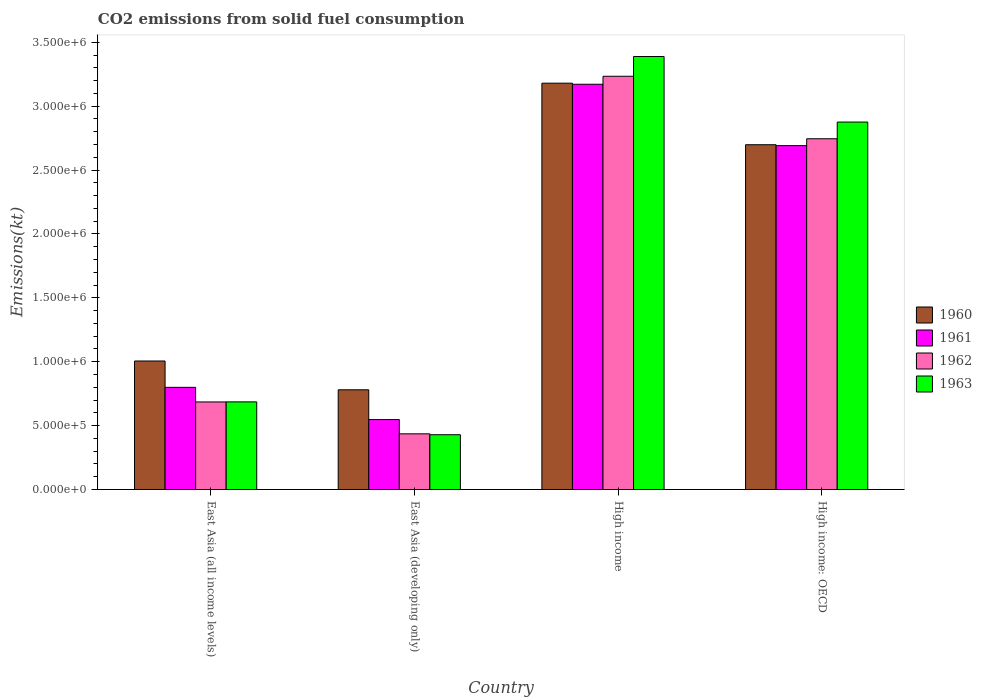How many different coloured bars are there?
Your answer should be compact. 4. Are the number of bars per tick equal to the number of legend labels?
Your answer should be very brief. Yes. How many bars are there on the 2nd tick from the left?
Your answer should be compact. 4. What is the label of the 1st group of bars from the left?
Your answer should be very brief. East Asia (all income levels). In how many cases, is the number of bars for a given country not equal to the number of legend labels?
Offer a terse response. 0. What is the amount of CO2 emitted in 1960 in East Asia (all income levels)?
Your answer should be compact. 1.01e+06. Across all countries, what is the maximum amount of CO2 emitted in 1962?
Offer a terse response. 3.23e+06. Across all countries, what is the minimum amount of CO2 emitted in 1963?
Offer a terse response. 4.29e+05. In which country was the amount of CO2 emitted in 1963 maximum?
Offer a terse response. High income. In which country was the amount of CO2 emitted in 1961 minimum?
Your answer should be compact. East Asia (developing only). What is the total amount of CO2 emitted in 1961 in the graph?
Your answer should be compact. 7.21e+06. What is the difference between the amount of CO2 emitted in 1961 in High income and that in High income: OECD?
Your answer should be compact. 4.80e+05. What is the difference between the amount of CO2 emitted in 1960 in East Asia (all income levels) and the amount of CO2 emitted in 1961 in High income: OECD?
Your response must be concise. -1.69e+06. What is the average amount of CO2 emitted in 1960 per country?
Provide a succinct answer. 1.92e+06. What is the difference between the amount of CO2 emitted of/in 1962 and amount of CO2 emitted of/in 1960 in East Asia (all income levels)?
Keep it short and to the point. -3.20e+05. What is the ratio of the amount of CO2 emitted in 1960 in East Asia (all income levels) to that in High income: OECD?
Keep it short and to the point. 0.37. Is the amount of CO2 emitted in 1960 in East Asia (all income levels) less than that in High income: OECD?
Your answer should be very brief. Yes. Is the difference between the amount of CO2 emitted in 1962 in East Asia (developing only) and High income greater than the difference between the amount of CO2 emitted in 1960 in East Asia (developing only) and High income?
Your answer should be compact. No. What is the difference between the highest and the second highest amount of CO2 emitted in 1961?
Your answer should be compact. 1.89e+06. What is the difference between the highest and the lowest amount of CO2 emitted in 1960?
Offer a terse response. 2.40e+06. In how many countries, is the amount of CO2 emitted in 1962 greater than the average amount of CO2 emitted in 1962 taken over all countries?
Make the answer very short. 2. Is the sum of the amount of CO2 emitted in 1961 in East Asia (all income levels) and High income greater than the maximum amount of CO2 emitted in 1960 across all countries?
Give a very brief answer. Yes. Is it the case that in every country, the sum of the amount of CO2 emitted in 1962 and amount of CO2 emitted in 1961 is greater than the sum of amount of CO2 emitted in 1963 and amount of CO2 emitted in 1960?
Offer a terse response. No. What does the 2nd bar from the right in East Asia (developing only) represents?
Offer a very short reply. 1962. Is it the case that in every country, the sum of the amount of CO2 emitted in 1962 and amount of CO2 emitted in 1961 is greater than the amount of CO2 emitted in 1963?
Keep it short and to the point. Yes. How many countries are there in the graph?
Your response must be concise. 4. Does the graph contain grids?
Make the answer very short. No. Where does the legend appear in the graph?
Your response must be concise. Center right. How many legend labels are there?
Provide a short and direct response. 4. How are the legend labels stacked?
Your answer should be compact. Vertical. What is the title of the graph?
Keep it short and to the point. CO2 emissions from solid fuel consumption. What is the label or title of the Y-axis?
Your answer should be very brief. Emissions(kt). What is the Emissions(kt) in 1960 in East Asia (all income levels)?
Make the answer very short. 1.01e+06. What is the Emissions(kt) in 1961 in East Asia (all income levels)?
Provide a succinct answer. 8.00e+05. What is the Emissions(kt) in 1962 in East Asia (all income levels)?
Keep it short and to the point. 6.85e+05. What is the Emissions(kt) of 1963 in East Asia (all income levels)?
Offer a terse response. 6.86e+05. What is the Emissions(kt) in 1960 in East Asia (developing only)?
Your answer should be compact. 7.80e+05. What is the Emissions(kt) of 1961 in East Asia (developing only)?
Make the answer very short. 5.48e+05. What is the Emissions(kt) of 1962 in East Asia (developing only)?
Ensure brevity in your answer.  4.36e+05. What is the Emissions(kt) of 1963 in East Asia (developing only)?
Your response must be concise. 4.29e+05. What is the Emissions(kt) in 1960 in High income?
Ensure brevity in your answer.  3.18e+06. What is the Emissions(kt) of 1961 in High income?
Keep it short and to the point. 3.17e+06. What is the Emissions(kt) of 1962 in High income?
Offer a very short reply. 3.23e+06. What is the Emissions(kt) in 1963 in High income?
Your answer should be very brief. 3.39e+06. What is the Emissions(kt) in 1960 in High income: OECD?
Your answer should be compact. 2.70e+06. What is the Emissions(kt) in 1961 in High income: OECD?
Provide a succinct answer. 2.69e+06. What is the Emissions(kt) of 1962 in High income: OECD?
Make the answer very short. 2.75e+06. What is the Emissions(kt) in 1963 in High income: OECD?
Ensure brevity in your answer.  2.88e+06. Across all countries, what is the maximum Emissions(kt) of 1960?
Ensure brevity in your answer.  3.18e+06. Across all countries, what is the maximum Emissions(kt) of 1961?
Your response must be concise. 3.17e+06. Across all countries, what is the maximum Emissions(kt) in 1962?
Make the answer very short. 3.23e+06. Across all countries, what is the maximum Emissions(kt) in 1963?
Your response must be concise. 3.39e+06. Across all countries, what is the minimum Emissions(kt) in 1960?
Your response must be concise. 7.80e+05. Across all countries, what is the minimum Emissions(kt) in 1961?
Make the answer very short. 5.48e+05. Across all countries, what is the minimum Emissions(kt) in 1962?
Offer a terse response. 4.36e+05. Across all countries, what is the minimum Emissions(kt) in 1963?
Your response must be concise. 4.29e+05. What is the total Emissions(kt) of 1960 in the graph?
Ensure brevity in your answer.  7.66e+06. What is the total Emissions(kt) of 1961 in the graph?
Offer a terse response. 7.21e+06. What is the total Emissions(kt) of 1962 in the graph?
Your response must be concise. 7.10e+06. What is the total Emissions(kt) of 1963 in the graph?
Offer a very short reply. 7.38e+06. What is the difference between the Emissions(kt) in 1960 in East Asia (all income levels) and that in East Asia (developing only)?
Make the answer very short. 2.25e+05. What is the difference between the Emissions(kt) of 1961 in East Asia (all income levels) and that in East Asia (developing only)?
Provide a short and direct response. 2.52e+05. What is the difference between the Emissions(kt) in 1962 in East Asia (all income levels) and that in East Asia (developing only)?
Offer a terse response. 2.50e+05. What is the difference between the Emissions(kt) of 1963 in East Asia (all income levels) and that in East Asia (developing only)?
Your answer should be very brief. 2.57e+05. What is the difference between the Emissions(kt) in 1960 in East Asia (all income levels) and that in High income?
Your response must be concise. -2.17e+06. What is the difference between the Emissions(kt) of 1961 in East Asia (all income levels) and that in High income?
Your answer should be compact. -2.37e+06. What is the difference between the Emissions(kt) of 1962 in East Asia (all income levels) and that in High income?
Offer a very short reply. -2.55e+06. What is the difference between the Emissions(kt) of 1963 in East Asia (all income levels) and that in High income?
Provide a succinct answer. -2.70e+06. What is the difference between the Emissions(kt) in 1960 in East Asia (all income levels) and that in High income: OECD?
Offer a terse response. -1.69e+06. What is the difference between the Emissions(kt) of 1961 in East Asia (all income levels) and that in High income: OECD?
Give a very brief answer. -1.89e+06. What is the difference between the Emissions(kt) of 1962 in East Asia (all income levels) and that in High income: OECD?
Offer a terse response. -2.06e+06. What is the difference between the Emissions(kt) of 1963 in East Asia (all income levels) and that in High income: OECD?
Make the answer very short. -2.19e+06. What is the difference between the Emissions(kt) in 1960 in East Asia (developing only) and that in High income?
Your answer should be compact. -2.40e+06. What is the difference between the Emissions(kt) of 1961 in East Asia (developing only) and that in High income?
Keep it short and to the point. -2.62e+06. What is the difference between the Emissions(kt) of 1962 in East Asia (developing only) and that in High income?
Offer a terse response. -2.80e+06. What is the difference between the Emissions(kt) of 1963 in East Asia (developing only) and that in High income?
Give a very brief answer. -2.96e+06. What is the difference between the Emissions(kt) in 1960 in East Asia (developing only) and that in High income: OECD?
Make the answer very short. -1.92e+06. What is the difference between the Emissions(kt) of 1961 in East Asia (developing only) and that in High income: OECD?
Provide a succinct answer. -2.14e+06. What is the difference between the Emissions(kt) of 1962 in East Asia (developing only) and that in High income: OECD?
Make the answer very short. -2.31e+06. What is the difference between the Emissions(kt) of 1963 in East Asia (developing only) and that in High income: OECD?
Keep it short and to the point. -2.45e+06. What is the difference between the Emissions(kt) of 1960 in High income and that in High income: OECD?
Your response must be concise. 4.82e+05. What is the difference between the Emissions(kt) in 1961 in High income and that in High income: OECD?
Your answer should be compact. 4.80e+05. What is the difference between the Emissions(kt) of 1962 in High income and that in High income: OECD?
Provide a short and direct response. 4.89e+05. What is the difference between the Emissions(kt) of 1963 in High income and that in High income: OECD?
Offer a terse response. 5.13e+05. What is the difference between the Emissions(kt) of 1960 in East Asia (all income levels) and the Emissions(kt) of 1961 in East Asia (developing only)?
Make the answer very short. 4.58e+05. What is the difference between the Emissions(kt) in 1960 in East Asia (all income levels) and the Emissions(kt) in 1962 in East Asia (developing only)?
Offer a terse response. 5.70e+05. What is the difference between the Emissions(kt) of 1960 in East Asia (all income levels) and the Emissions(kt) of 1963 in East Asia (developing only)?
Give a very brief answer. 5.77e+05. What is the difference between the Emissions(kt) of 1961 in East Asia (all income levels) and the Emissions(kt) of 1962 in East Asia (developing only)?
Your answer should be very brief. 3.64e+05. What is the difference between the Emissions(kt) in 1961 in East Asia (all income levels) and the Emissions(kt) in 1963 in East Asia (developing only)?
Ensure brevity in your answer.  3.71e+05. What is the difference between the Emissions(kt) of 1962 in East Asia (all income levels) and the Emissions(kt) of 1963 in East Asia (developing only)?
Offer a very short reply. 2.57e+05. What is the difference between the Emissions(kt) in 1960 in East Asia (all income levels) and the Emissions(kt) in 1961 in High income?
Provide a short and direct response. -2.17e+06. What is the difference between the Emissions(kt) in 1960 in East Asia (all income levels) and the Emissions(kt) in 1962 in High income?
Give a very brief answer. -2.23e+06. What is the difference between the Emissions(kt) of 1960 in East Asia (all income levels) and the Emissions(kt) of 1963 in High income?
Make the answer very short. -2.38e+06. What is the difference between the Emissions(kt) in 1961 in East Asia (all income levels) and the Emissions(kt) in 1962 in High income?
Ensure brevity in your answer.  -2.43e+06. What is the difference between the Emissions(kt) of 1961 in East Asia (all income levels) and the Emissions(kt) of 1963 in High income?
Provide a succinct answer. -2.59e+06. What is the difference between the Emissions(kt) of 1962 in East Asia (all income levels) and the Emissions(kt) of 1963 in High income?
Keep it short and to the point. -2.70e+06. What is the difference between the Emissions(kt) in 1960 in East Asia (all income levels) and the Emissions(kt) in 1961 in High income: OECD?
Offer a very short reply. -1.69e+06. What is the difference between the Emissions(kt) of 1960 in East Asia (all income levels) and the Emissions(kt) of 1962 in High income: OECD?
Make the answer very short. -1.74e+06. What is the difference between the Emissions(kt) in 1960 in East Asia (all income levels) and the Emissions(kt) in 1963 in High income: OECD?
Provide a short and direct response. -1.87e+06. What is the difference between the Emissions(kt) of 1961 in East Asia (all income levels) and the Emissions(kt) of 1962 in High income: OECD?
Provide a short and direct response. -1.95e+06. What is the difference between the Emissions(kt) of 1961 in East Asia (all income levels) and the Emissions(kt) of 1963 in High income: OECD?
Ensure brevity in your answer.  -2.08e+06. What is the difference between the Emissions(kt) of 1962 in East Asia (all income levels) and the Emissions(kt) of 1963 in High income: OECD?
Provide a short and direct response. -2.19e+06. What is the difference between the Emissions(kt) in 1960 in East Asia (developing only) and the Emissions(kt) in 1961 in High income?
Your answer should be compact. -2.39e+06. What is the difference between the Emissions(kt) of 1960 in East Asia (developing only) and the Emissions(kt) of 1962 in High income?
Offer a very short reply. -2.45e+06. What is the difference between the Emissions(kt) of 1960 in East Asia (developing only) and the Emissions(kt) of 1963 in High income?
Offer a very short reply. -2.61e+06. What is the difference between the Emissions(kt) in 1961 in East Asia (developing only) and the Emissions(kt) in 1962 in High income?
Your answer should be compact. -2.69e+06. What is the difference between the Emissions(kt) in 1961 in East Asia (developing only) and the Emissions(kt) in 1963 in High income?
Your answer should be compact. -2.84e+06. What is the difference between the Emissions(kt) in 1962 in East Asia (developing only) and the Emissions(kt) in 1963 in High income?
Ensure brevity in your answer.  -2.95e+06. What is the difference between the Emissions(kt) in 1960 in East Asia (developing only) and the Emissions(kt) in 1961 in High income: OECD?
Offer a terse response. -1.91e+06. What is the difference between the Emissions(kt) in 1960 in East Asia (developing only) and the Emissions(kt) in 1962 in High income: OECD?
Give a very brief answer. -1.96e+06. What is the difference between the Emissions(kt) in 1960 in East Asia (developing only) and the Emissions(kt) in 1963 in High income: OECD?
Provide a short and direct response. -2.10e+06. What is the difference between the Emissions(kt) of 1961 in East Asia (developing only) and the Emissions(kt) of 1962 in High income: OECD?
Keep it short and to the point. -2.20e+06. What is the difference between the Emissions(kt) in 1961 in East Asia (developing only) and the Emissions(kt) in 1963 in High income: OECD?
Make the answer very short. -2.33e+06. What is the difference between the Emissions(kt) in 1962 in East Asia (developing only) and the Emissions(kt) in 1963 in High income: OECD?
Offer a very short reply. -2.44e+06. What is the difference between the Emissions(kt) of 1960 in High income and the Emissions(kt) of 1961 in High income: OECD?
Offer a terse response. 4.89e+05. What is the difference between the Emissions(kt) of 1960 in High income and the Emissions(kt) of 1962 in High income: OECD?
Your answer should be very brief. 4.35e+05. What is the difference between the Emissions(kt) in 1960 in High income and the Emissions(kt) in 1963 in High income: OECD?
Offer a terse response. 3.04e+05. What is the difference between the Emissions(kt) in 1961 in High income and the Emissions(kt) in 1962 in High income: OECD?
Offer a terse response. 4.27e+05. What is the difference between the Emissions(kt) of 1961 in High income and the Emissions(kt) of 1963 in High income: OECD?
Offer a terse response. 2.96e+05. What is the difference between the Emissions(kt) of 1962 in High income and the Emissions(kt) of 1963 in High income: OECD?
Provide a succinct answer. 3.58e+05. What is the average Emissions(kt) in 1960 per country?
Your answer should be compact. 1.92e+06. What is the average Emissions(kt) of 1961 per country?
Make the answer very short. 1.80e+06. What is the average Emissions(kt) of 1962 per country?
Offer a terse response. 1.78e+06. What is the average Emissions(kt) in 1963 per country?
Offer a very short reply. 1.84e+06. What is the difference between the Emissions(kt) in 1960 and Emissions(kt) in 1961 in East Asia (all income levels)?
Give a very brief answer. 2.06e+05. What is the difference between the Emissions(kt) in 1960 and Emissions(kt) in 1962 in East Asia (all income levels)?
Your response must be concise. 3.20e+05. What is the difference between the Emissions(kt) in 1960 and Emissions(kt) in 1963 in East Asia (all income levels)?
Keep it short and to the point. 3.20e+05. What is the difference between the Emissions(kt) of 1961 and Emissions(kt) of 1962 in East Asia (all income levels)?
Give a very brief answer. 1.14e+05. What is the difference between the Emissions(kt) in 1961 and Emissions(kt) in 1963 in East Asia (all income levels)?
Provide a short and direct response. 1.14e+05. What is the difference between the Emissions(kt) of 1962 and Emissions(kt) of 1963 in East Asia (all income levels)?
Your answer should be very brief. -517.54. What is the difference between the Emissions(kt) of 1960 and Emissions(kt) of 1961 in East Asia (developing only)?
Provide a short and direct response. 2.33e+05. What is the difference between the Emissions(kt) of 1960 and Emissions(kt) of 1962 in East Asia (developing only)?
Offer a very short reply. 3.45e+05. What is the difference between the Emissions(kt) of 1960 and Emissions(kt) of 1963 in East Asia (developing only)?
Keep it short and to the point. 3.52e+05. What is the difference between the Emissions(kt) of 1961 and Emissions(kt) of 1962 in East Asia (developing only)?
Your answer should be compact. 1.12e+05. What is the difference between the Emissions(kt) in 1961 and Emissions(kt) in 1963 in East Asia (developing only)?
Provide a succinct answer. 1.19e+05. What is the difference between the Emissions(kt) of 1962 and Emissions(kt) of 1963 in East Asia (developing only)?
Give a very brief answer. 6890.94. What is the difference between the Emissions(kt) in 1960 and Emissions(kt) in 1961 in High income?
Offer a terse response. 8354.42. What is the difference between the Emissions(kt) of 1960 and Emissions(kt) of 1962 in High income?
Keep it short and to the point. -5.41e+04. What is the difference between the Emissions(kt) in 1960 and Emissions(kt) in 1963 in High income?
Your answer should be compact. -2.09e+05. What is the difference between the Emissions(kt) in 1961 and Emissions(kt) in 1962 in High income?
Your response must be concise. -6.24e+04. What is the difference between the Emissions(kt) of 1961 and Emissions(kt) of 1963 in High income?
Your answer should be compact. -2.17e+05. What is the difference between the Emissions(kt) in 1962 and Emissions(kt) in 1963 in High income?
Provide a short and direct response. -1.55e+05. What is the difference between the Emissions(kt) of 1960 and Emissions(kt) of 1961 in High income: OECD?
Give a very brief answer. 7090.26. What is the difference between the Emissions(kt) in 1960 and Emissions(kt) in 1962 in High income: OECD?
Offer a terse response. -4.67e+04. What is the difference between the Emissions(kt) of 1960 and Emissions(kt) of 1963 in High income: OECD?
Offer a very short reply. -1.77e+05. What is the difference between the Emissions(kt) in 1961 and Emissions(kt) in 1962 in High income: OECD?
Your response must be concise. -5.38e+04. What is the difference between the Emissions(kt) of 1961 and Emissions(kt) of 1963 in High income: OECD?
Your response must be concise. -1.85e+05. What is the difference between the Emissions(kt) in 1962 and Emissions(kt) in 1963 in High income: OECD?
Your answer should be compact. -1.31e+05. What is the ratio of the Emissions(kt) of 1960 in East Asia (all income levels) to that in East Asia (developing only)?
Provide a succinct answer. 1.29. What is the ratio of the Emissions(kt) of 1961 in East Asia (all income levels) to that in East Asia (developing only)?
Provide a short and direct response. 1.46. What is the ratio of the Emissions(kt) in 1962 in East Asia (all income levels) to that in East Asia (developing only)?
Ensure brevity in your answer.  1.57. What is the ratio of the Emissions(kt) in 1963 in East Asia (all income levels) to that in East Asia (developing only)?
Ensure brevity in your answer.  1.6. What is the ratio of the Emissions(kt) in 1960 in East Asia (all income levels) to that in High income?
Your answer should be compact. 0.32. What is the ratio of the Emissions(kt) in 1961 in East Asia (all income levels) to that in High income?
Give a very brief answer. 0.25. What is the ratio of the Emissions(kt) of 1962 in East Asia (all income levels) to that in High income?
Offer a terse response. 0.21. What is the ratio of the Emissions(kt) of 1963 in East Asia (all income levels) to that in High income?
Your answer should be compact. 0.2. What is the ratio of the Emissions(kt) in 1960 in East Asia (all income levels) to that in High income: OECD?
Keep it short and to the point. 0.37. What is the ratio of the Emissions(kt) in 1961 in East Asia (all income levels) to that in High income: OECD?
Offer a terse response. 0.3. What is the ratio of the Emissions(kt) in 1962 in East Asia (all income levels) to that in High income: OECD?
Offer a very short reply. 0.25. What is the ratio of the Emissions(kt) in 1963 in East Asia (all income levels) to that in High income: OECD?
Ensure brevity in your answer.  0.24. What is the ratio of the Emissions(kt) in 1960 in East Asia (developing only) to that in High income?
Offer a terse response. 0.25. What is the ratio of the Emissions(kt) of 1961 in East Asia (developing only) to that in High income?
Your response must be concise. 0.17. What is the ratio of the Emissions(kt) in 1962 in East Asia (developing only) to that in High income?
Your answer should be very brief. 0.13. What is the ratio of the Emissions(kt) of 1963 in East Asia (developing only) to that in High income?
Offer a very short reply. 0.13. What is the ratio of the Emissions(kt) of 1960 in East Asia (developing only) to that in High income: OECD?
Provide a succinct answer. 0.29. What is the ratio of the Emissions(kt) of 1961 in East Asia (developing only) to that in High income: OECD?
Make the answer very short. 0.2. What is the ratio of the Emissions(kt) in 1962 in East Asia (developing only) to that in High income: OECD?
Your response must be concise. 0.16. What is the ratio of the Emissions(kt) in 1963 in East Asia (developing only) to that in High income: OECD?
Offer a very short reply. 0.15. What is the ratio of the Emissions(kt) in 1960 in High income to that in High income: OECD?
Your response must be concise. 1.18. What is the ratio of the Emissions(kt) in 1961 in High income to that in High income: OECD?
Your response must be concise. 1.18. What is the ratio of the Emissions(kt) of 1962 in High income to that in High income: OECD?
Ensure brevity in your answer.  1.18. What is the ratio of the Emissions(kt) in 1963 in High income to that in High income: OECD?
Offer a very short reply. 1.18. What is the difference between the highest and the second highest Emissions(kt) in 1960?
Your answer should be very brief. 4.82e+05. What is the difference between the highest and the second highest Emissions(kt) of 1961?
Ensure brevity in your answer.  4.80e+05. What is the difference between the highest and the second highest Emissions(kt) in 1962?
Ensure brevity in your answer.  4.89e+05. What is the difference between the highest and the second highest Emissions(kt) of 1963?
Offer a terse response. 5.13e+05. What is the difference between the highest and the lowest Emissions(kt) of 1960?
Your response must be concise. 2.40e+06. What is the difference between the highest and the lowest Emissions(kt) in 1961?
Provide a succinct answer. 2.62e+06. What is the difference between the highest and the lowest Emissions(kt) of 1962?
Your answer should be very brief. 2.80e+06. What is the difference between the highest and the lowest Emissions(kt) in 1963?
Ensure brevity in your answer.  2.96e+06. 